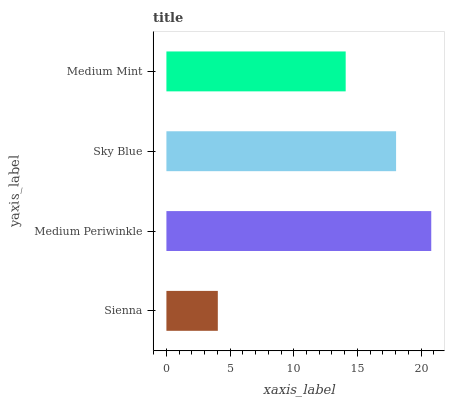Is Sienna the minimum?
Answer yes or no. Yes. Is Medium Periwinkle the maximum?
Answer yes or no. Yes. Is Sky Blue the minimum?
Answer yes or no. No. Is Sky Blue the maximum?
Answer yes or no. No. Is Medium Periwinkle greater than Sky Blue?
Answer yes or no. Yes. Is Sky Blue less than Medium Periwinkle?
Answer yes or no. Yes. Is Sky Blue greater than Medium Periwinkle?
Answer yes or no. No. Is Medium Periwinkle less than Sky Blue?
Answer yes or no. No. Is Sky Blue the high median?
Answer yes or no. Yes. Is Medium Mint the low median?
Answer yes or no. Yes. Is Medium Mint the high median?
Answer yes or no. No. Is Sienna the low median?
Answer yes or no. No. 